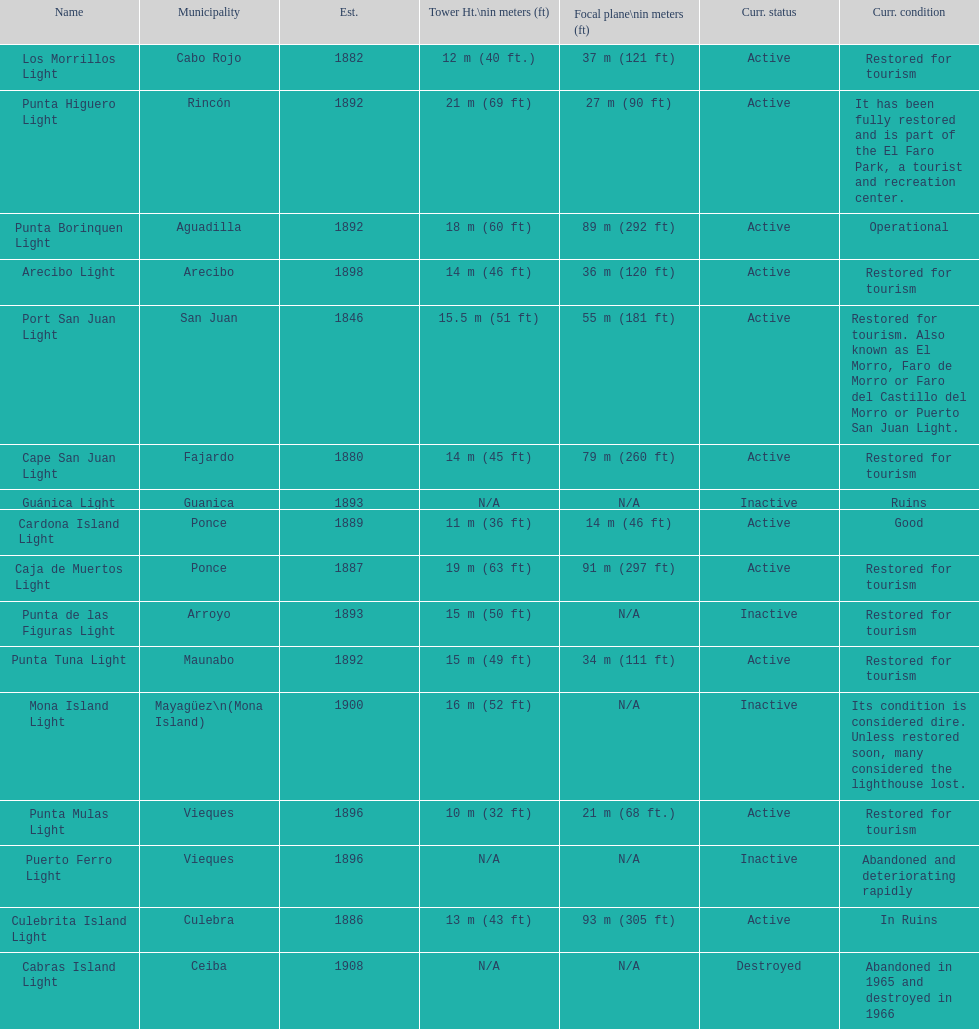Number of lighthouses that begin with the letter p 7. 